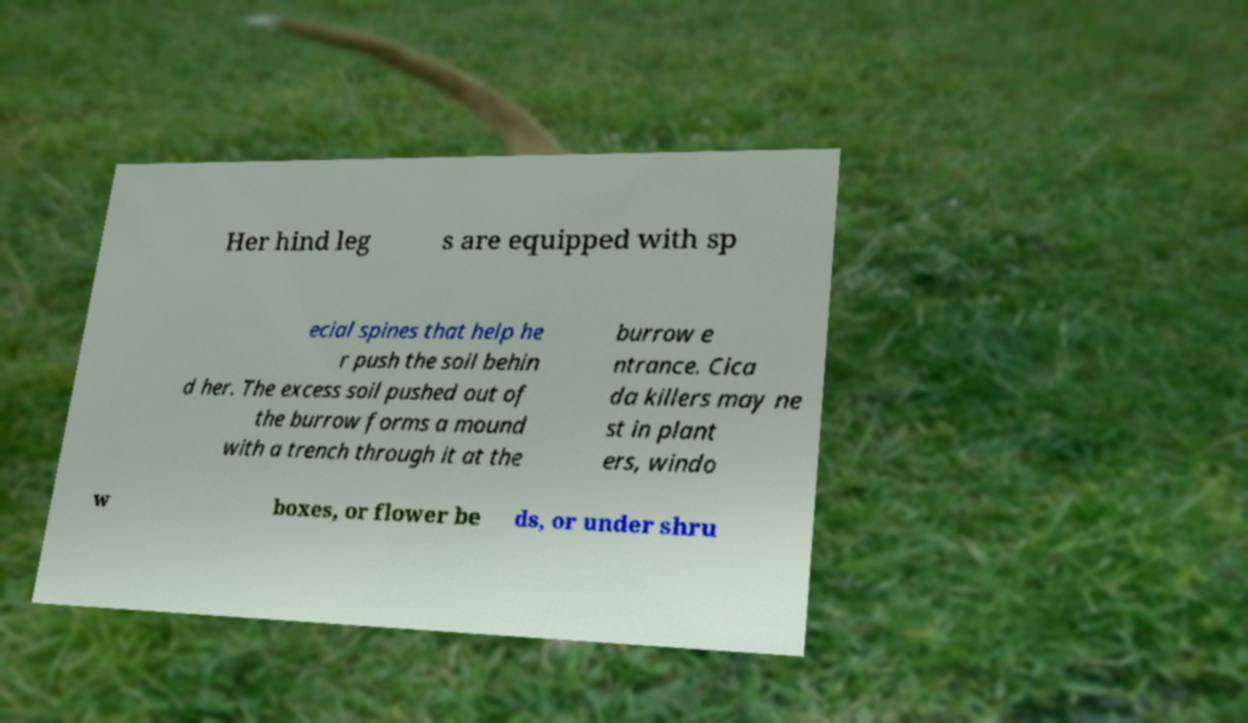Could you assist in decoding the text presented in this image and type it out clearly? Her hind leg s are equipped with sp ecial spines that help he r push the soil behin d her. The excess soil pushed out of the burrow forms a mound with a trench through it at the burrow e ntrance. Cica da killers may ne st in plant ers, windo w boxes, or flower be ds, or under shru 